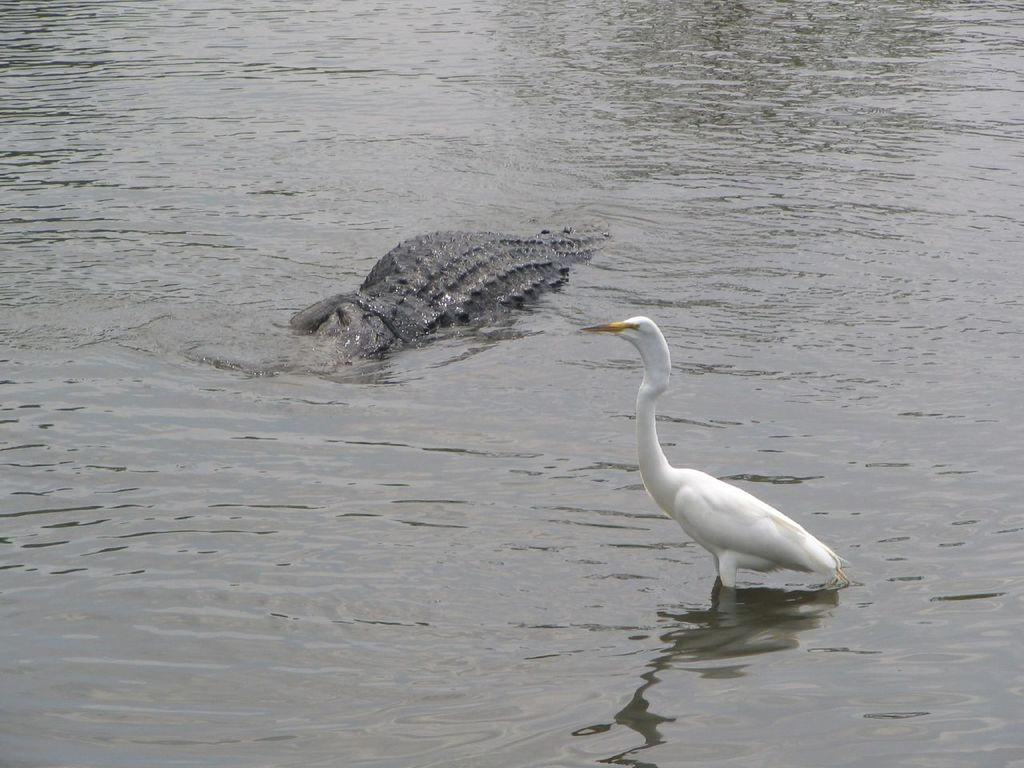What is present in the image? There is water visible in the image, along with a bird and a crocodile. Can you describe the bird in the water? The bird is in the water, but its specific features are not clear from the image. What other animal is present in the water? There is a crocodile in the water. What type of cabbage is being used as an attraction for the bird and crocodile in the image? There is no cabbage present in the image, nor is there any indication that it is being used as an attraction for the bird and crocodile. 